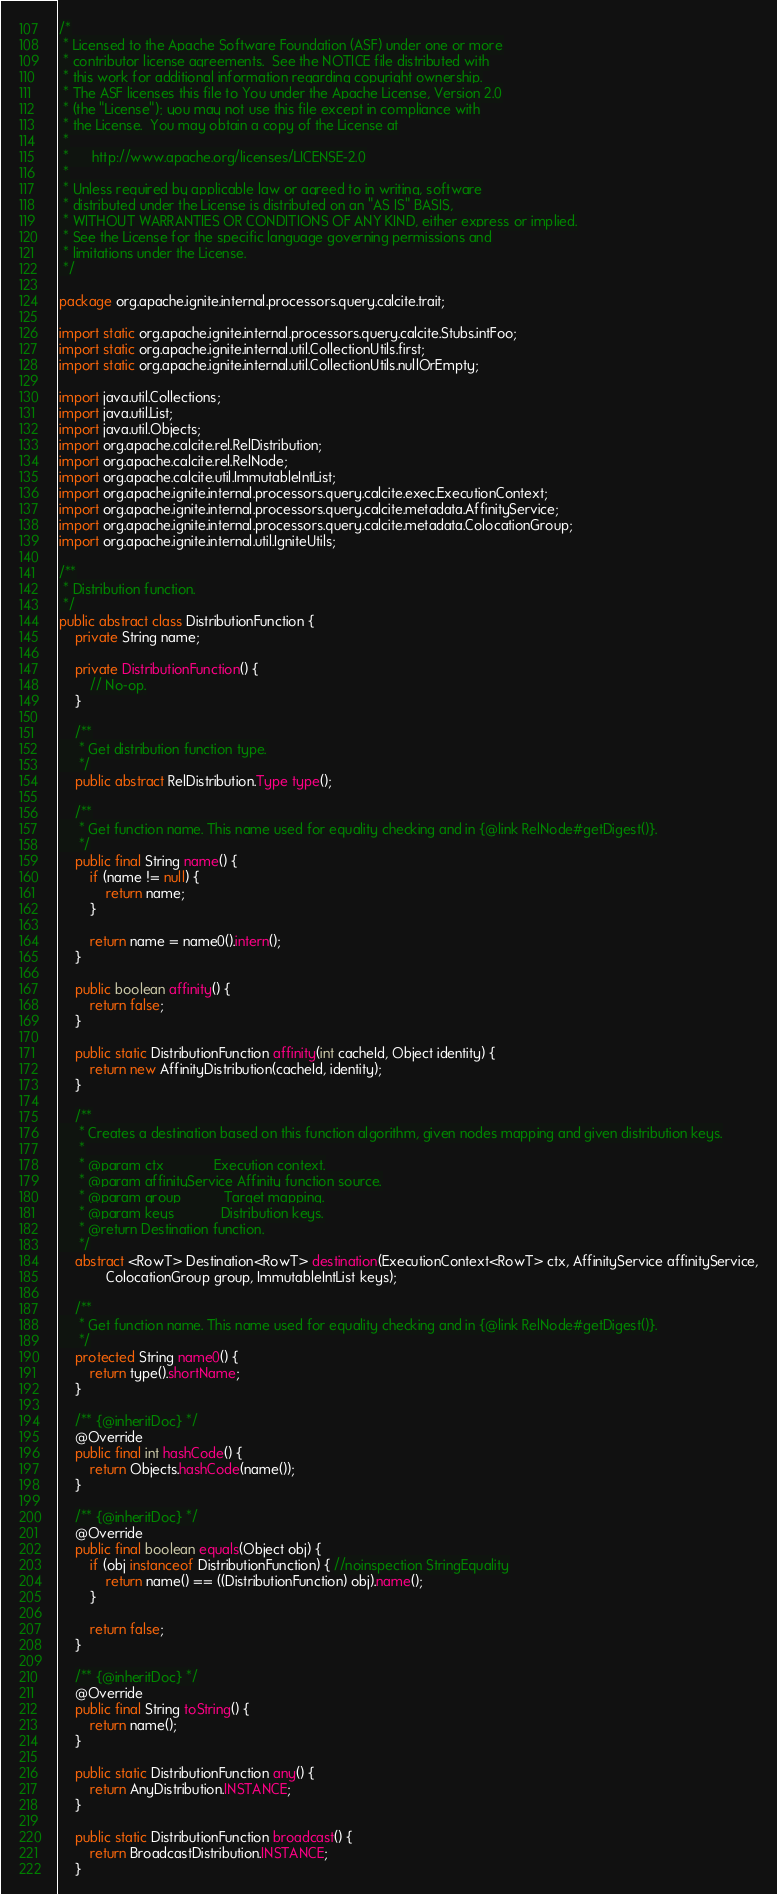Convert code to text. <code><loc_0><loc_0><loc_500><loc_500><_Java_>/*
 * Licensed to the Apache Software Foundation (ASF) under one or more
 * contributor license agreements.  See the NOTICE file distributed with
 * this work for additional information regarding copyright ownership.
 * The ASF licenses this file to You under the Apache License, Version 2.0
 * (the "License"); you may not use this file except in compliance with
 * the License.  You may obtain a copy of the License at
 *
 *      http://www.apache.org/licenses/LICENSE-2.0
 *
 * Unless required by applicable law or agreed to in writing, software
 * distributed under the License is distributed on an "AS IS" BASIS,
 * WITHOUT WARRANTIES OR CONDITIONS OF ANY KIND, either express or implied.
 * See the License for the specific language governing permissions and
 * limitations under the License.
 */

package org.apache.ignite.internal.processors.query.calcite.trait;

import static org.apache.ignite.internal.processors.query.calcite.Stubs.intFoo;
import static org.apache.ignite.internal.util.CollectionUtils.first;
import static org.apache.ignite.internal.util.CollectionUtils.nullOrEmpty;

import java.util.Collections;
import java.util.List;
import java.util.Objects;
import org.apache.calcite.rel.RelDistribution;
import org.apache.calcite.rel.RelNode;
import org.apache.calcite.util.ImmutableIntList;
import org.apache.ignite.internal.processors.query.calcite.exec.ExecutionContext;
import org.apache.ignite.internal.processors.query.calcite.metadata.AffinityService;
import org.apache.ignite.internal.processors.query.calcite.metadata.ColocationGroup;
import org.apache.ignite.internal.util.IgniteUtils;

/**
 * Distribution function.
 */
public abstract class DistributionFunction {
    private String name;

    private DistributionFunction() {
        // No-op.
    }

    /**
     * Get distribution function type.
     */
    public abstract RelDistribution.Type type();

    /**
     * Get function name. This name used for equality checking and in {@link RelNode#getDigest()}.
     */
    public final String name() {
        if (name != null) {
            return name;
        }

        return name = name0().intern();
    }

    public boolean affinity() {
        return false;
    }

    public static DistributionFunction affinity(int cacheId, Object identity) {
        return new AffinityDistribution(cacheId, identity);
    }

    /**
     * Creates a destination based on this function algorithm, given nodes mapping and given distribution keys.
     *
     * @param ctx             Execution context.
     * @param affinityService Affinity function source.
     * @param group           Target mapping.
     * @param keys            Distribution keys.
     * @return Destination function.
     */
    abstract <RowT> Destination<RowT> destination(ExecutionContext<RowT> ctx, AffinityService affinityService,
            ColocationGroup group, ImmutableIntList keys);

    /**
     * Get function name. This name used for equality checking and in {@link RelNode#getDigest()}.
     */
    protected String name0() {
        return type().shortName;
    }

    /** {@inheritDoc} */
    @Override
    public final int hashCode() {
        return Objects.hashCode(name());
    }

    /** {@inheritDoc} */
    @Override
    public final boolean equals(Object obj) {
        if (obj instanceof DistributionFunction) { //noinspection StringEquality
            return name() == ((DistributionFunction) obj).name();
        }

        return false;
    }

    /** {@inheritDoc} */
    @Override
    public final String toString() {
        return name();
    }

    public static DistributionFunction any() {
        return AnyDistribution.INSTANCE;
    }

    public static DistributionFunction broadcast() {
        return BroadcastDistribution.INSTANCE;
    }
</code> 